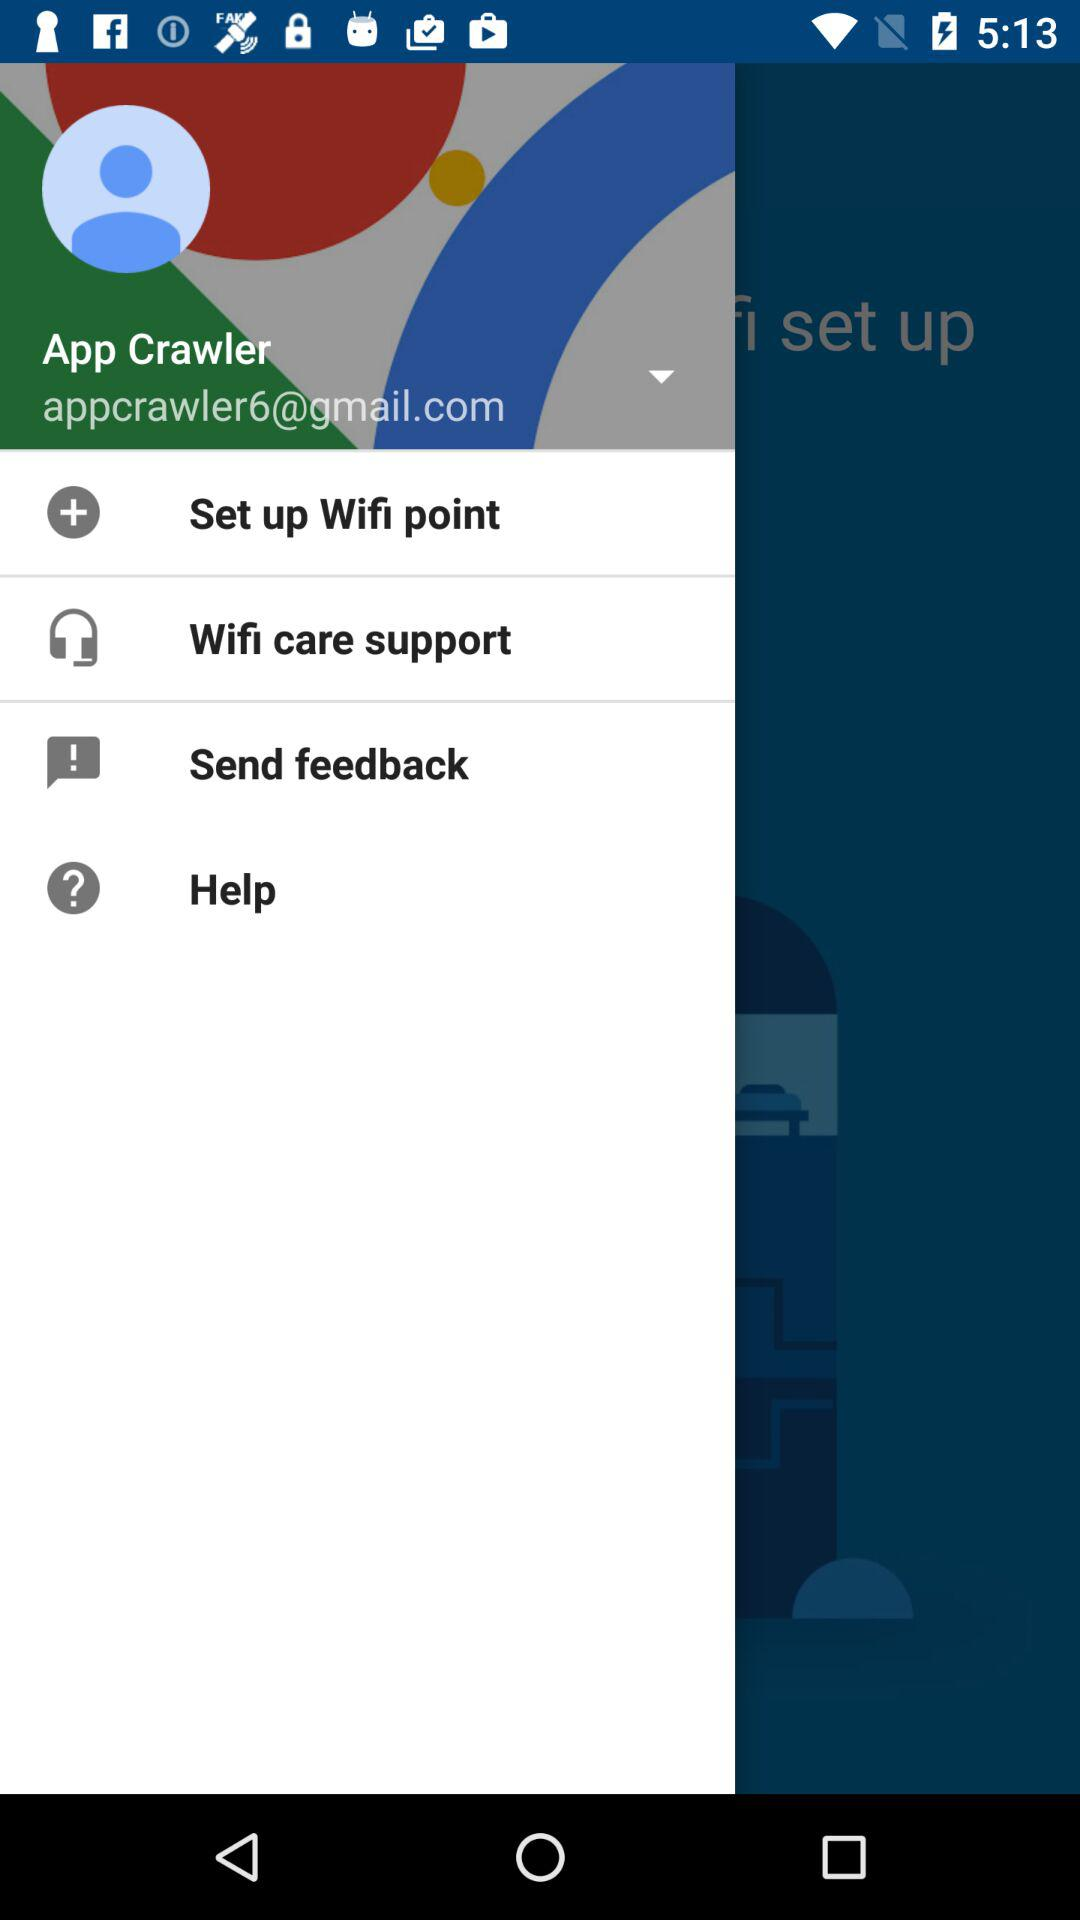What is the email address of the user? The email address is "appcrawler6@gmail.com". 